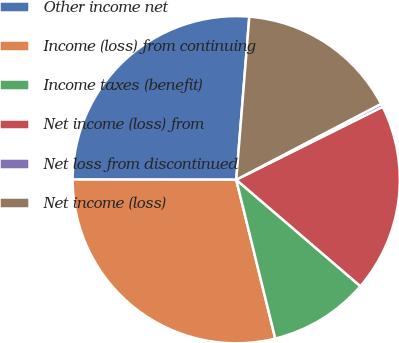Convert chart. <chart><loc_0><loc_0><loc_500><loc_500><pie_chart><fcel>Other income net<fcel>Income (loss) from continuing<fcel>Income taxes (benefit)<fcel>Net income (loss) from<fcel>Net loss from discontinued<fcel>Net income (loss)<nl><fcel>26.26%<fcel>28.85%<fcel>9.88%<fcel>18.64%<fcel>0.32%<fcel>16.05%<nl></chart> 